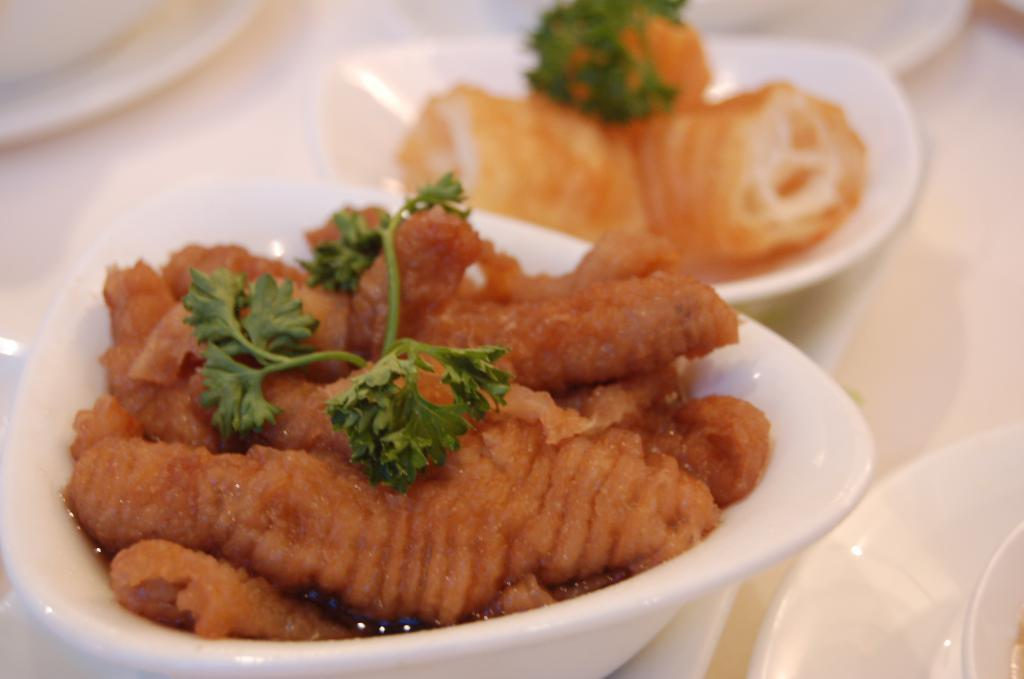What type of food is in the bowls in the image? The food appears to be flesh with coriander on top. What can be seen on the right side of the image? There are plates on the right side of the image. Where are the bowls and plates located? The bowls and plates are placed on a table. Can you see a rifle being used to prepare the food in the image? There is no rifle present in the image, and it is not involved in the preparation of the food. 